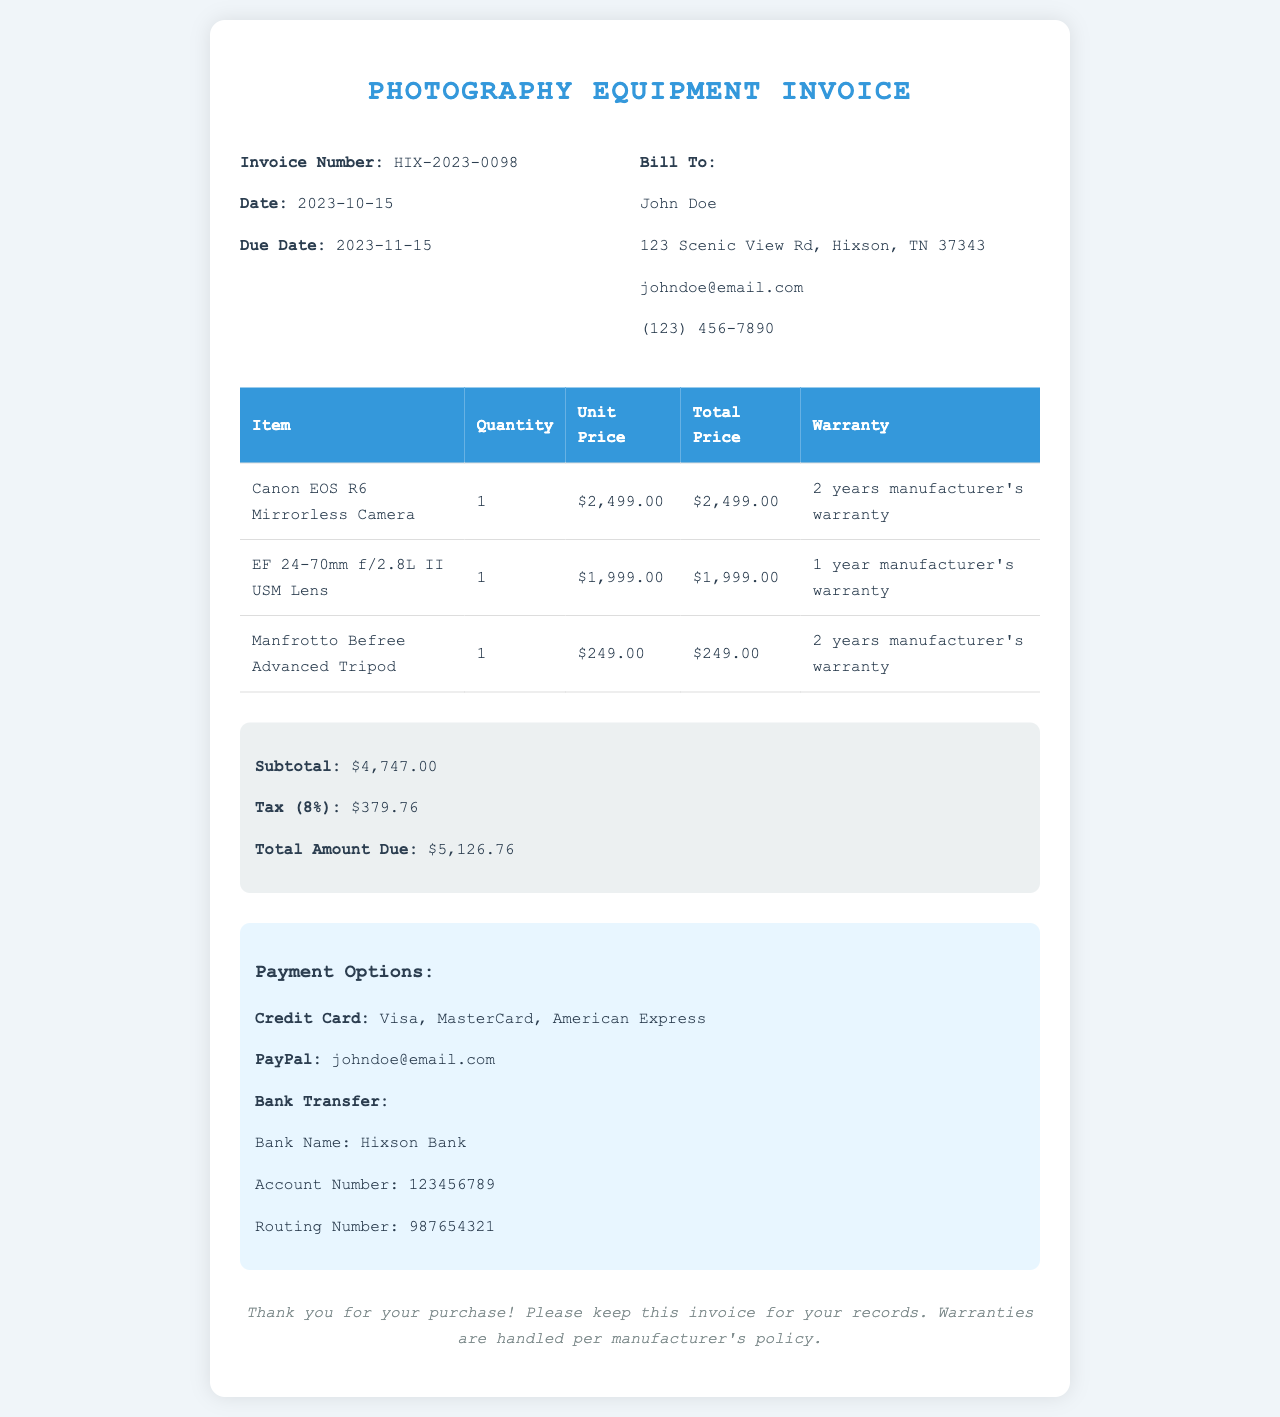What is the invoice number? The invoice number is specified in the document and is HIX-2023-0098.
Answer: HIX-2023-0098 What is the total amount due? The total amount due is calculated from the subtotal and tax provided in the document, which amounts to $5,126.76.
Answer: $5,126.76 What is the purchase date? The purchase date can be found under the invoice details, which states it is 2023-10-15.
Answer: 2023-10-15 How long is the warranty for the Canon EOS R6 Mirrorless Camera? The warranty period for the Canon EOS R6 is indicated in the document as 2 years.
Answer: 2 years What payment methods are available? The document lists several payment methods to provide options, including credit card, PayPal, and bank transfer.
Answer: Credit Card, PayPal, Bank Transfer What is the subtotal amount? The subtotal amount before tax is detailed in the document as $4,747.00.
Answer: $4,747.00 Who is the bill to? The name of the person being billed is presented in the invoice details, listed as John Doe.
Answer: John Doe What is the tax rate applied? The document states that the tax is calculated at a rate of 8%.
Answer: 8% 